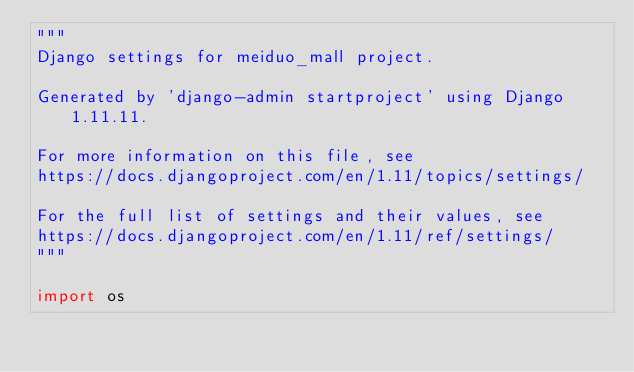<code> <loc_0><loc_0><loc_500><loc_500><_Python_>"""
Django settings for meiduo_mall project.

Generated by 'django-admin startproject' using Django 1.11.11.

For more information on this file, see
https://docs.djangoproject.com/en/1.11/topics/settings/

For the full list of settings and their values, see
https://docs.djangoproject.com/en/1.11/ref/settings/
"""

import os
</code> 